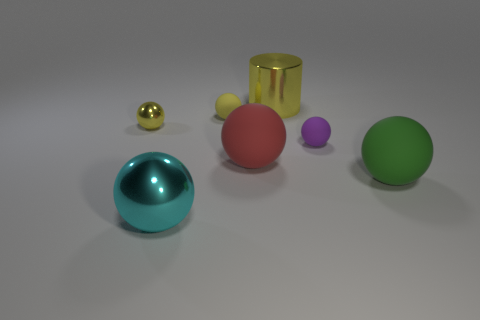Are there fewer small yellow shiny spheres that are to the right of the purple rubber ball than small spheres in front of the small yellow metal object?
Your response must be concise. Yes. There is a cyan sphere; what number of small purple matte things are in front of it?
Ensure brevity in your answer.  0. Is the shape of the small rubber thing behind the small purple sphere the same as the big green matte object in front of the yellow metal ball?
Provide a succinct answer. Yes. What number of other things are there of the same color as the cylinder?
Offer a terse response. 2. The big thing that is behind the yellow metallic thing that is in front of the yellow sphere that is on the right side of the large cyan shiny thing is made of what material?
Offer a terse response. Metal. What is the material of the small object that is to the right of the matte ball behind the tiny yellow metal object?
Provide a succinct answer. Rubber. Are there fewer red spheres to the left of the small yellow metallic sphere than purple balls?
Make the answer very short. Yes. There is a small matte thing to the right of the big metal cylinder; what shape is it?
Offer a very short reply. Sphere. There is a cyan ball; is it the same size as the rubber ball behind the tiny purple matte object?
Keep it short and to the point. No. Is there a purple object that has the same material as the large red object?
Keep it short and to the point. Yes. 